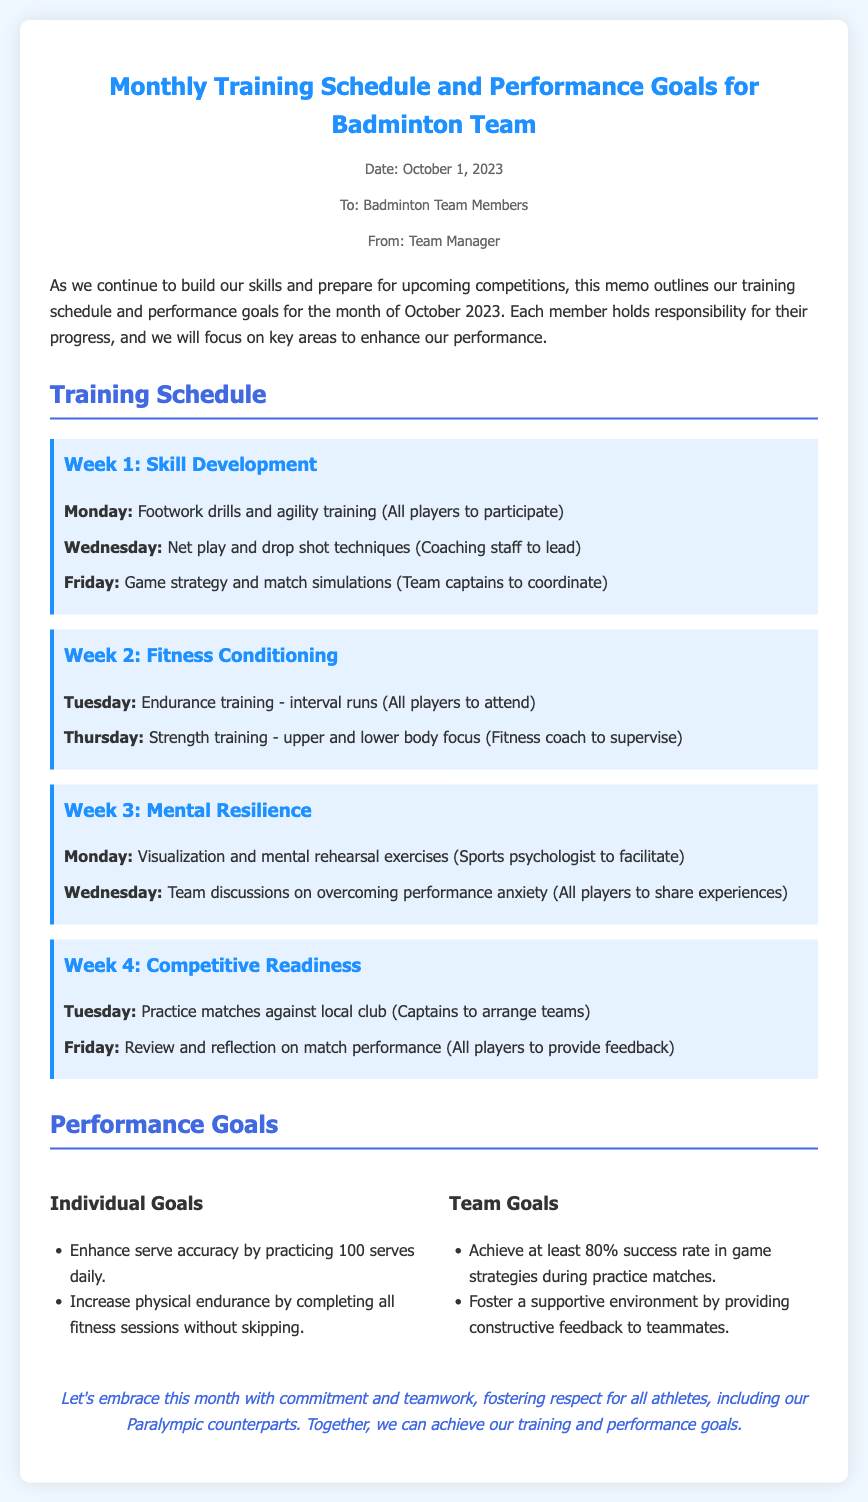What is the date of the memo? The date of the memo is specifically mentioned at the top under the meta section.
Answer: October 1, 2023 Who is the memo addressed to? The recipient of the memo is listed in the meta section, indicating the intended audience.
Answer: Badminton Team Members What is the focus area for Week 2? The focus for Week 2 is outlined in the corresponding section, detailing the scheduled activities for that week.
Answer: Fitness Conditioning How many practices are scheduled for Week 4? The number of practices can be counted from the list of sessions in Week 4's section of the document.
Answer: Two What is one of the individual goals listed? Individual goals are provided, and one can be retrieved directly from the goals section.
Answer: Enhance serve accuracy by practicing 100 serves daily What percentage success rate is targeted for team game strategies? The document specifies a clear performance goal regarding the target success rate during practice matches.
Answer: 80% Who leads the net play training session? Information regarding who conducts each session can be found in the training schedule.
Answer: Coaching staff What session focuses on mental resilience? The specific sessions dedicated to enhancing mental toughness are outlined in the training schedule.
Answer: Visualization and mental rehearsal exercises What type of training is mentioned for Week 1? The document contains specific types of training for each week and identifies the main theme for Week 1.
Answer: Skill Development 